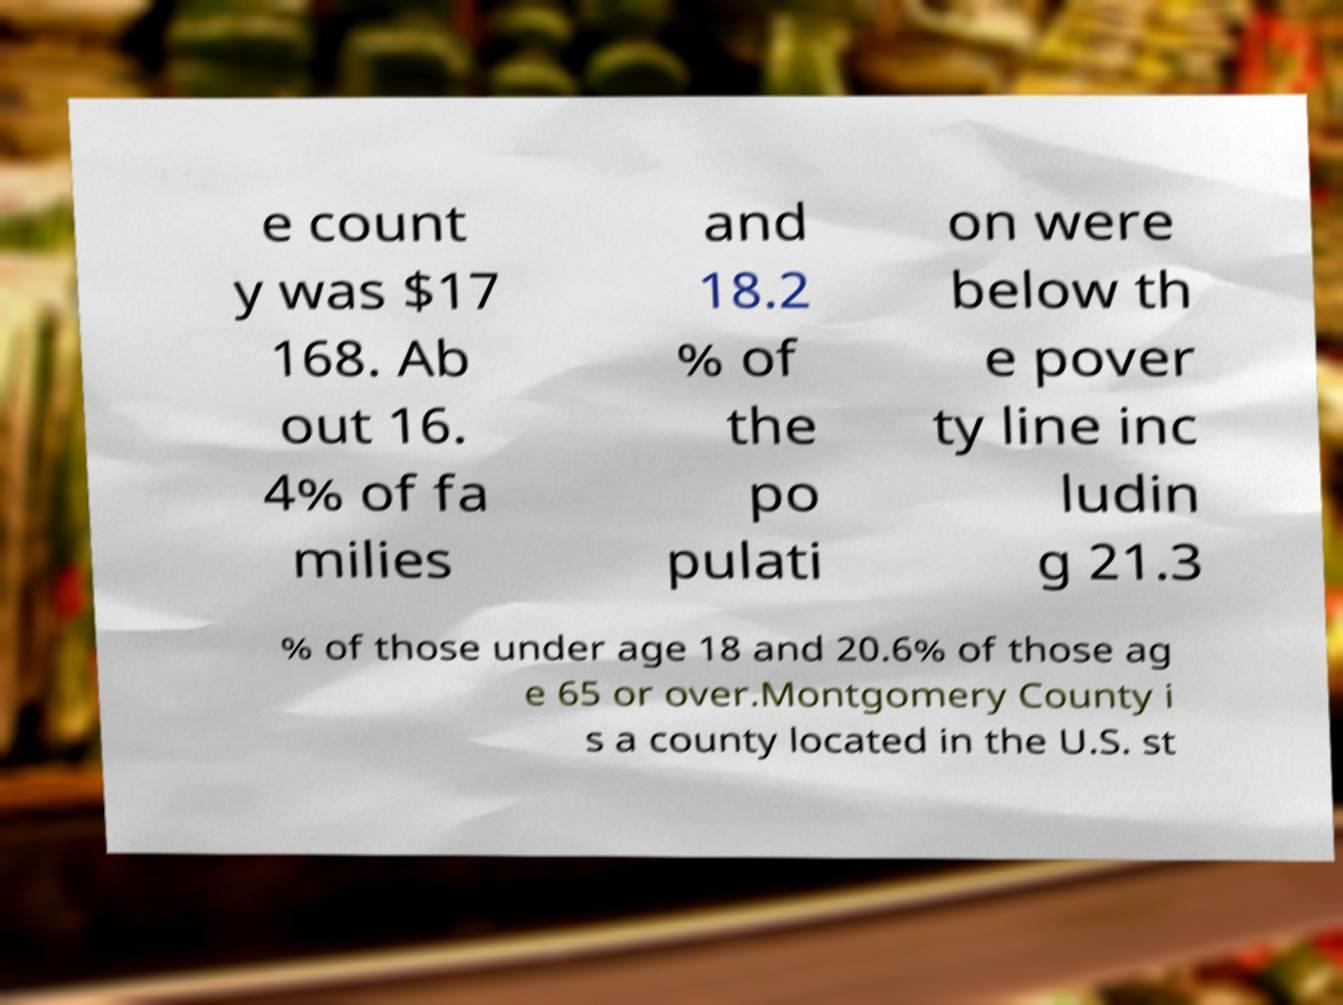There's text embedded in this image that I need extracted. Can you transcribe it verbatim? e count y was $17 168. Ab out 16. 4% of fa milies and 18.2 % of the po pulati on were below th e pover ty line inc ludin g 21.3 % of those under age 18 and 20.6% of those ag e 65 or over.Montgomery County i s a county located in the U.S. st 